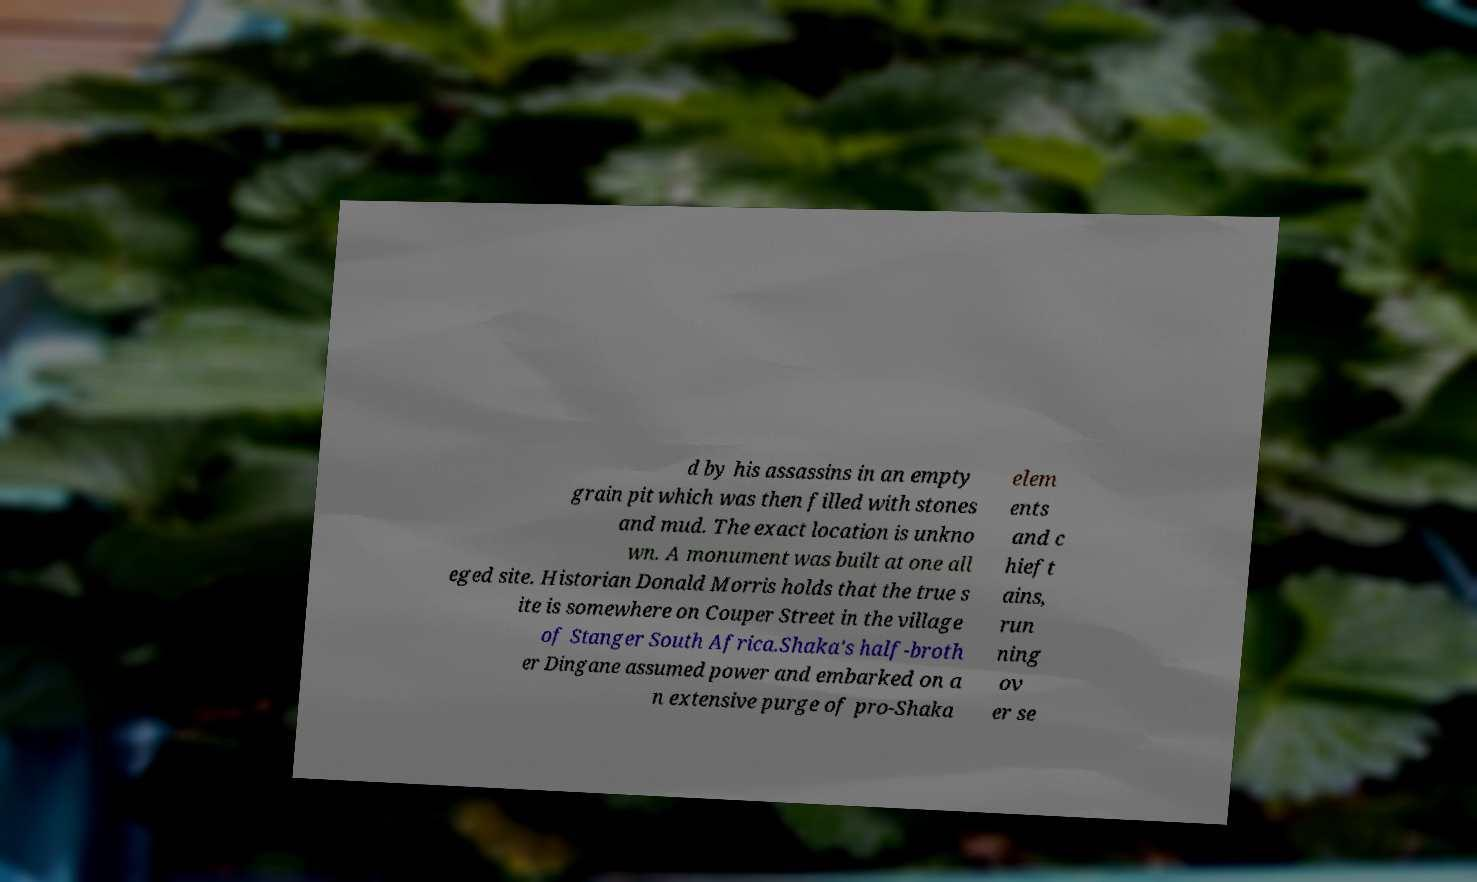Can you read and provide the text displayed in the image?This photo seems to have some interesting text. Can you extract and type it out for me? d by his assassins in an empty grain pit which was then filled with stones and mud. The exact location is unkno wn. A monument was built at one all eged site. Historian Donald Morris holds that the true s ite is somewhere on Couper Street in the village of Stanger South Africa.Shaka's half-broth er Dingane assumed power and embarked on a n extensive purge of pro-Shaka elem ents and c hieft ains, run ning ov er se 